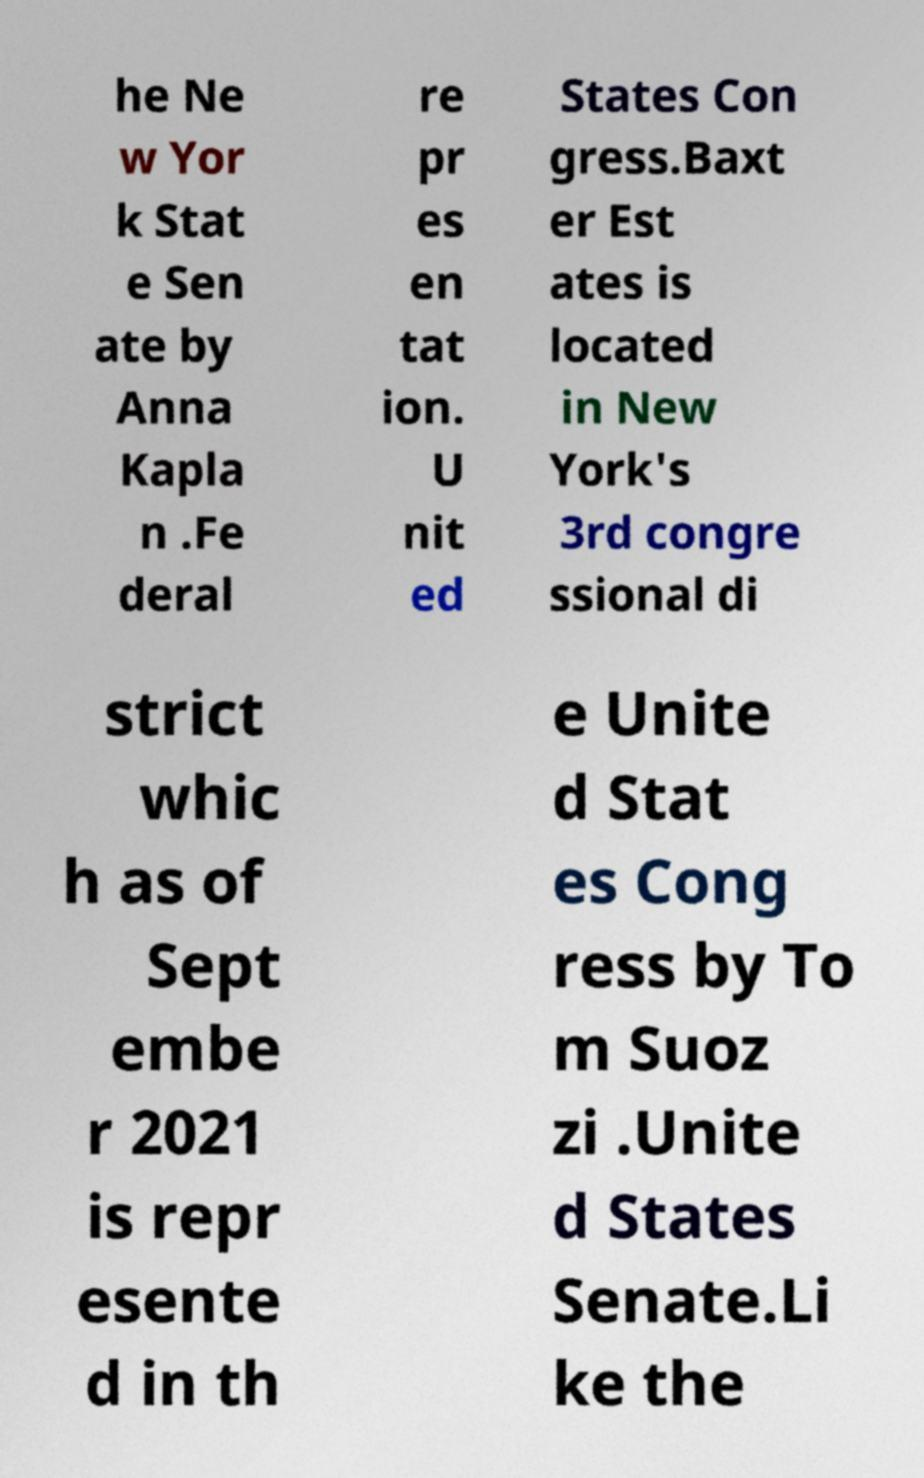Please identify and transcribe the text found in this image. he Ne w Yor k Stat e Sen ate by Anna Kapla n .Fe deral re pr es en tat ion. U nit ed States Con gress.Baxt er Est ates is located in New York's 3rd congre ssional di strict whic h as of Sept embe r 2021 is repr esente d in th e Unite d Stat es Cong ress by To m Suoz zi .Unite d States Senate.Li ke the 